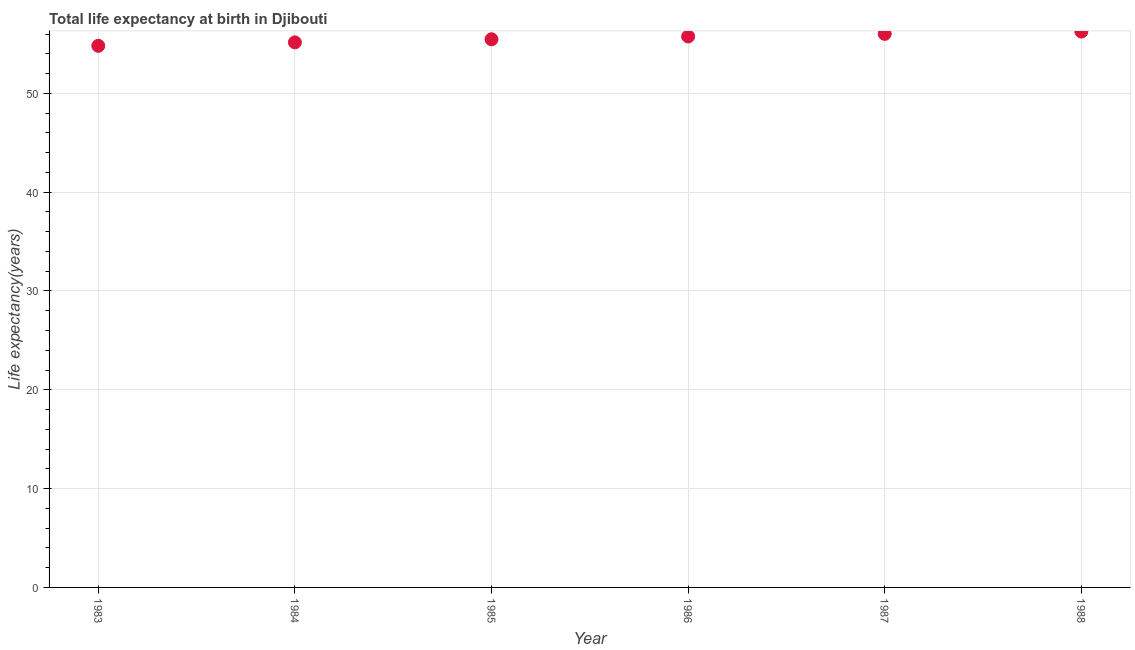What is the life expectancy at birth in 1985?
Keep it short and to the point. 55.47. Across all years, what is the maximum life expectancy at birth?
Your answer should be very brief. 56.26. Across all years, what is the minimum life expectancy at birth?
Offer a very short reply. 54.81. What is the sum of the life expectancy at birth?
Offer a very short reply. 333.47. What is the difference between the life expectancy at birth in 1984 and 1987?
Provide a succinct answer. -0.86. What is the average life expectancy at birth per year?
Ensure brevity in your answer.  55.58. What is the median life expectancy at birth?
Keep it short and to the point. 55.61. What is the ratio of the life expectancy at birth in 1983 to that in 1988?
Your answer should be very brief. 0.97. Is the life expectancy at birth in 1984 less than that in 1985?
Make the answer very short. Yes. What is the difference between the highest and the second highest life expectancy at birth?
Ensure brevity in your answer.  0.24. What is the difference between the highest and the lowest life expectancy at birth?
Your response must be concise. 1.44. In how many years, is the life expectancy at birth greater than the average life expectancy at birth taken over all years?
Provide a succinct answer. 3. Does the life expectancy at birth monotonically increase over the years?
Give a very brief answer. Yes. How many dotlines are there?
Offer a very short reply. 1. How many years are there in the graph?
Offer a very short reply. 6. What is the title of the graph?
Your response must be concise. Total life expectancy at birth in Djibouti. What is the label or title of the Y-axis?
Your answer should be very brief. Life expectancy(years). What is the Life expectancy(years) in 1983?
Make the answer very short. 54.81. What is the Life expectancy(years) in 1984?
Your answer should be very brief. 55.16. What is the Life expectancy(years) in 1985?
Make the answer very short. 55.47. What is the Life expectancy(years) in 1986?
Give a very brief answer. 55.76. What is the Life expectancy(years) in 1987?
Make the answer very short. 56.02. What is the Life expectancy(years) in 1988?
Give a very brief answer. 56.26. What is the difference between the Life expectancy(years) in 1983 and 1984?
Offer a very short reply. -0.35. What is the difference between the Life expectancy(years) in 1983 and 1985?
Provide a short and direct response. -0.66. What is the difference between the Life expectancy(years) in 1983 and 1986?
Offer a terse response. -0.95. What is the difference between the Life expectancy(years) in 1983 and 1987?
Offer a terse response. -1.21. What is the difference between the Life expectancy(years) in 1983 and 1988?
Keep it short and to the point. -1.44. What is the difference between the Life expectancy(years) in 1984 and 1985?
Give a very brief answer. -0.31. What is the difference between the Life expectancy(years) in 1984 and 1986?
Your response must be concise. -0.6. What is the difference between the Life expectancy(years) in 1984 and 1987?
Give a very brief answer. -0.86. What is the difference between the Life expectancy(years) in 1984 and 1988?
Your response must be concise. -1.1. What is the difference between the Life expectancy(years) in 1985 and 1986?
Offer a very short reply. -0.28. What is the difference between the Life expectancy(years) in 1985 and 1987?
Your answer should be compact. -0.54. What is the difference between the Life expectancy(years) in 1985 and 1988?
Ensure brevity in your answer.  -0.78. What is the difference between the Life expectancy(years) in 1986 and 1987?
Make the answer very short. -0.26. What is the difference between the Life expectancy(years) in 1986 and 1988?
Ensure brevity in your answer.  -0.5. What is the difference between the Life expectancy(years) in 1987 and 1988?
Offer a terse response. -0.24. What is the ratio of the Life expectancy(years) in 1983 to that in 1984?
Ensure brevity in your answer.  0.99. What is the ratio of the Life expectancy(years) in 1983 to that in 1985?
Offer a very short reply. 0.99. What is the ratio of the Life expectancy(years) in 1984 to that in 1985?
Your response must be concise. 0.99. What is the ratio of the Life expectancy(years) in 1985 to that in 1986?
Keep it short and to the point. 0.99. What is the ratio of the Life expectancy(years) in 1985 to that in 1987?
Offer a very short reply. 0.99. What is the ratio of the Life expectancy(years) in 1986 to that in 1988?
Offer a terse response. 0.99. 